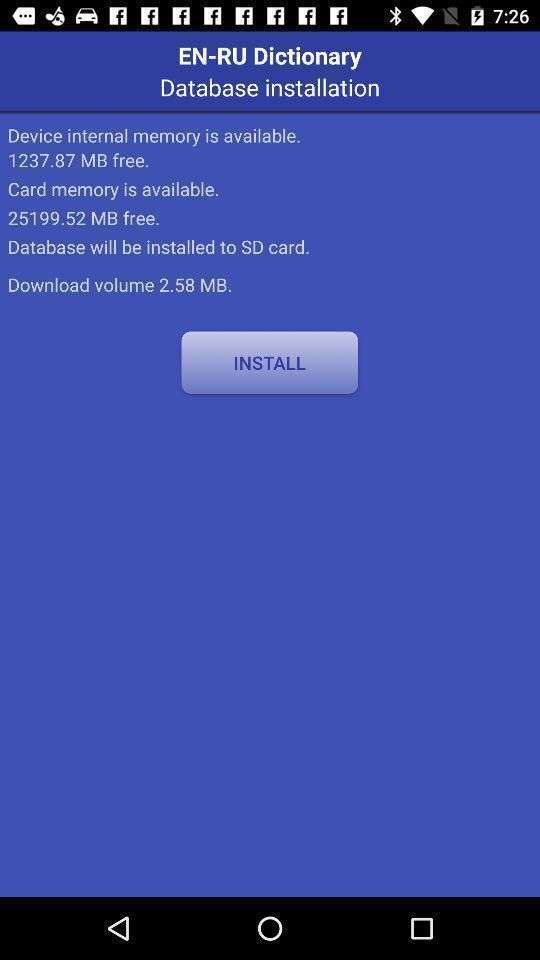Describe the key features of this screenshot. Screen shows installation page. 